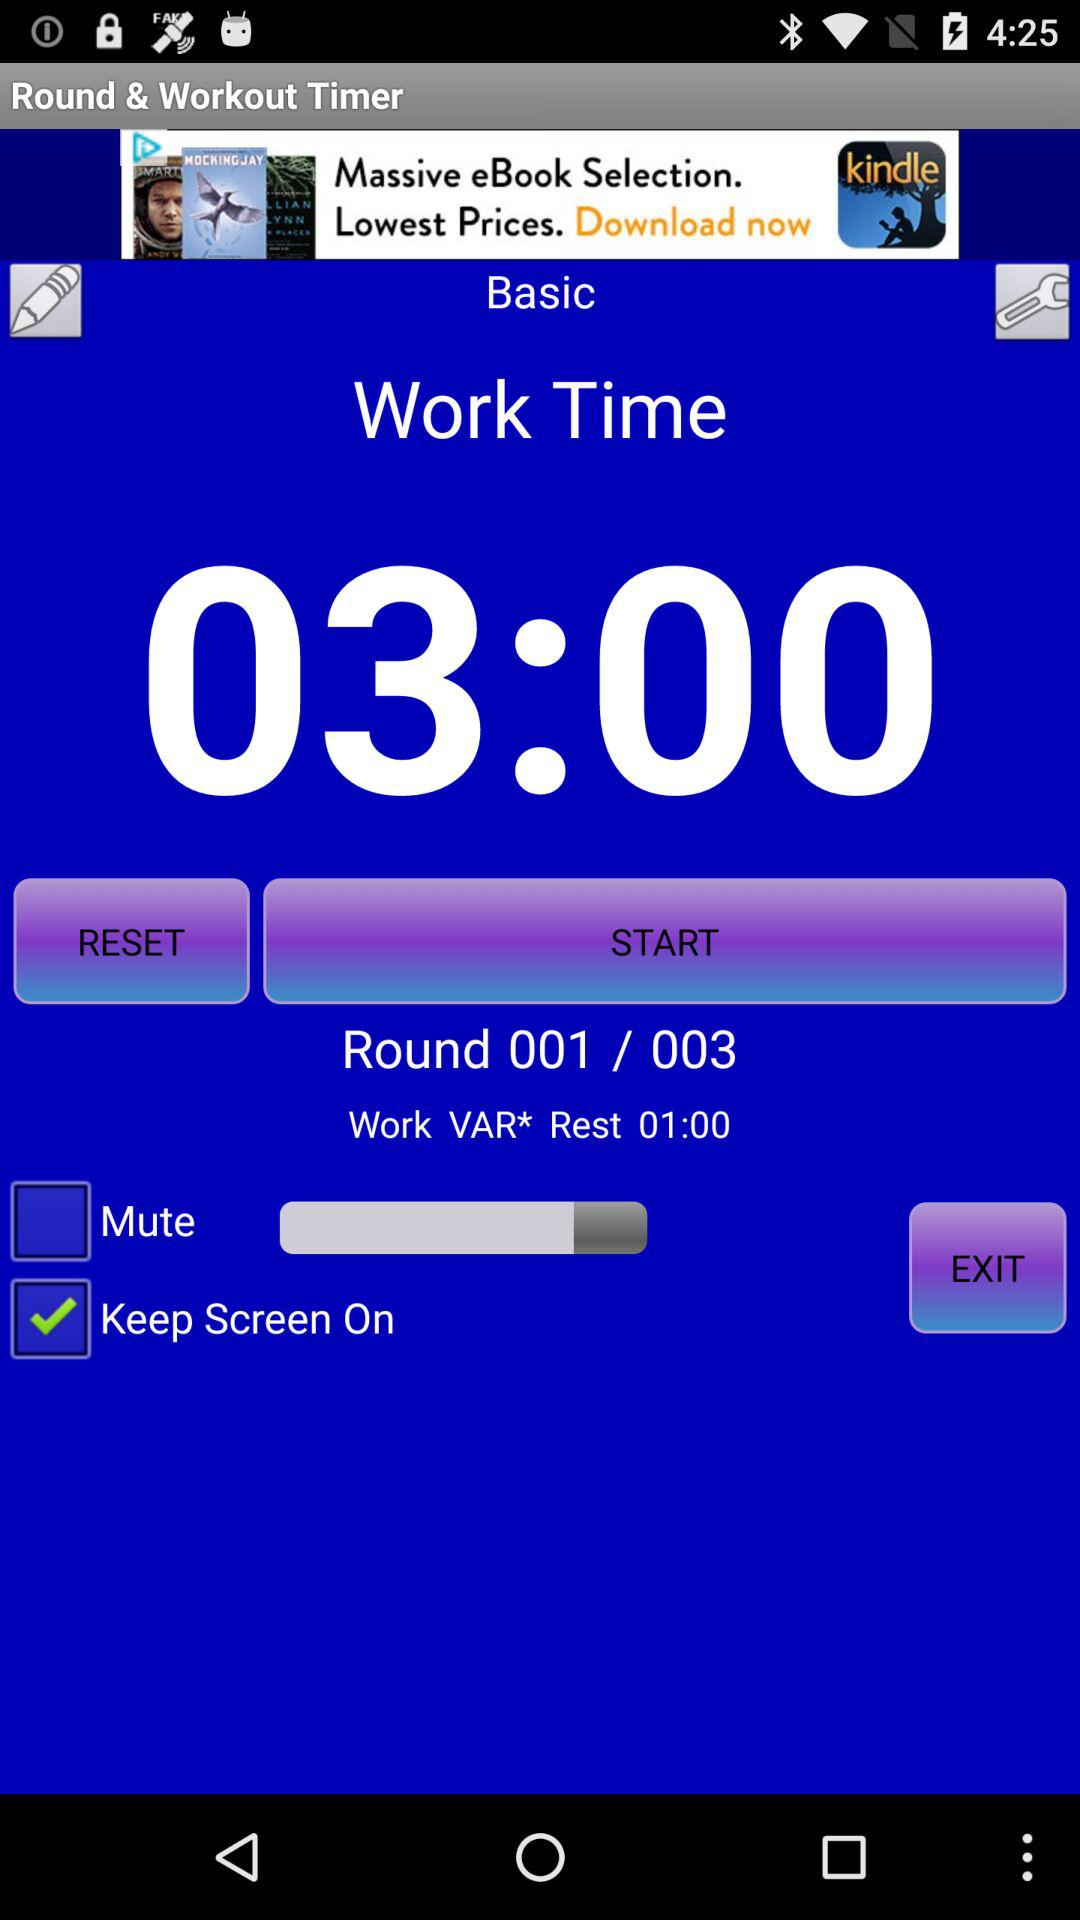What is the status of the "Keep Screen On" setting? The status is "on". 